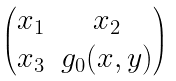Convert formula to latex. <formula><loc_0><loc_0><loc_500><loc_500>\begin{pmatrix} x _ { 1 } & x _ { 2 } \\ x _ { 3 } & g _ { 0 } ( x , y ) \end{pmatrix}</formula> 